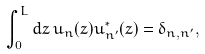<formula> <loc_0><loc_0><loc_500><loc_500>\int _ { 0 } ^ { L } d z \, u _ { n } ( z ) u _ { n ^ { \prime } } ^ { * } ( z ) = \delta _ { n , n ^ { \prime } } ,</formula> 